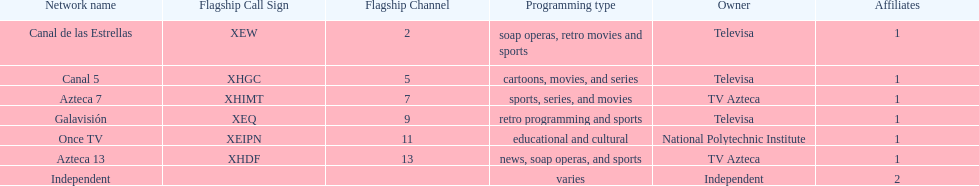What is the difference between the number of affiliates galavision has and the number of affiliates azteca 13 has? 0. 